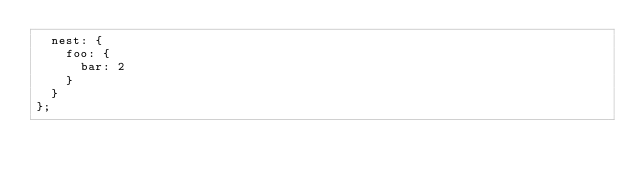Convert code to text. <code><loc_0><loc_0><loc_500><loc_500><_JavaScript_>  nest: {
    foo: {
      bar: 2
    }
  }
};
</code> 